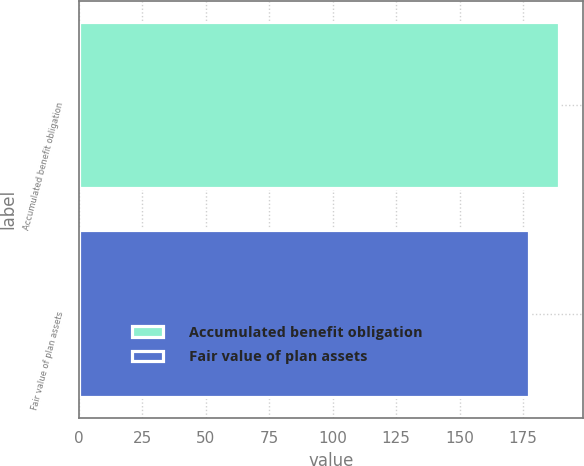<chart> <loc_0><loc_0><loc_500><loc_500><bar_chart><fcel>Accumulated benefit obligation<fcel>Fair value of plan assets<nl><fcel>189.2<fcel>177.4<nl></chart> 